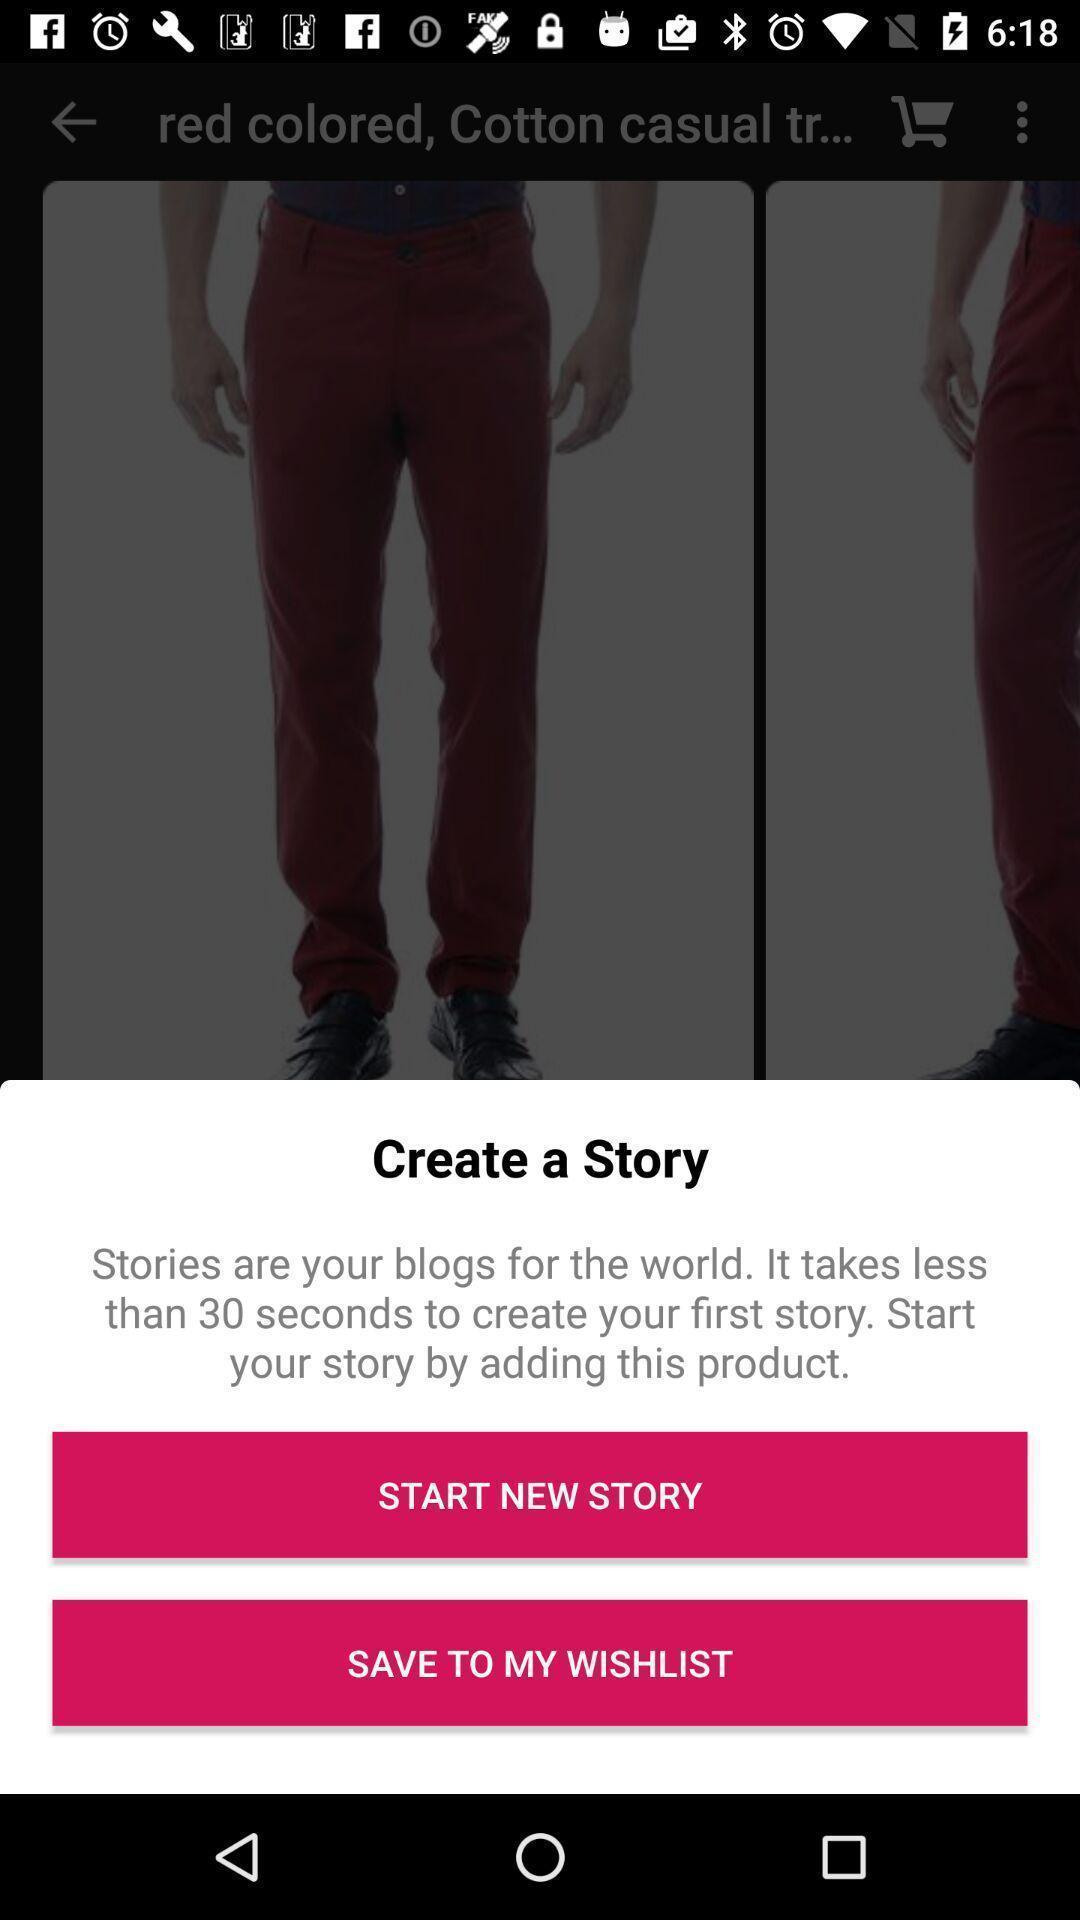What is the overall content of this screenshot? Pop up showing story options. 